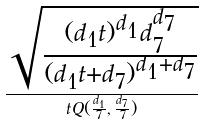Convert formula to latex. <formula><loc_0><loc_0><loc_500><loc_500>\frac { \sqrt { \frac { ( d _ { 1 } t ) ^ { d _ { 1 } } d _ { 7 } ^ { d _ { 7 } } } { ( d _ { 1 } t + d _ { 7 } ) ^ { d _ { 1 } + d _ { 7 } } } } } { t Q ( \frac { d _ { 1 } } { 7 } , \frac { d _ { 7 } } { 7 } ) }</formula> 